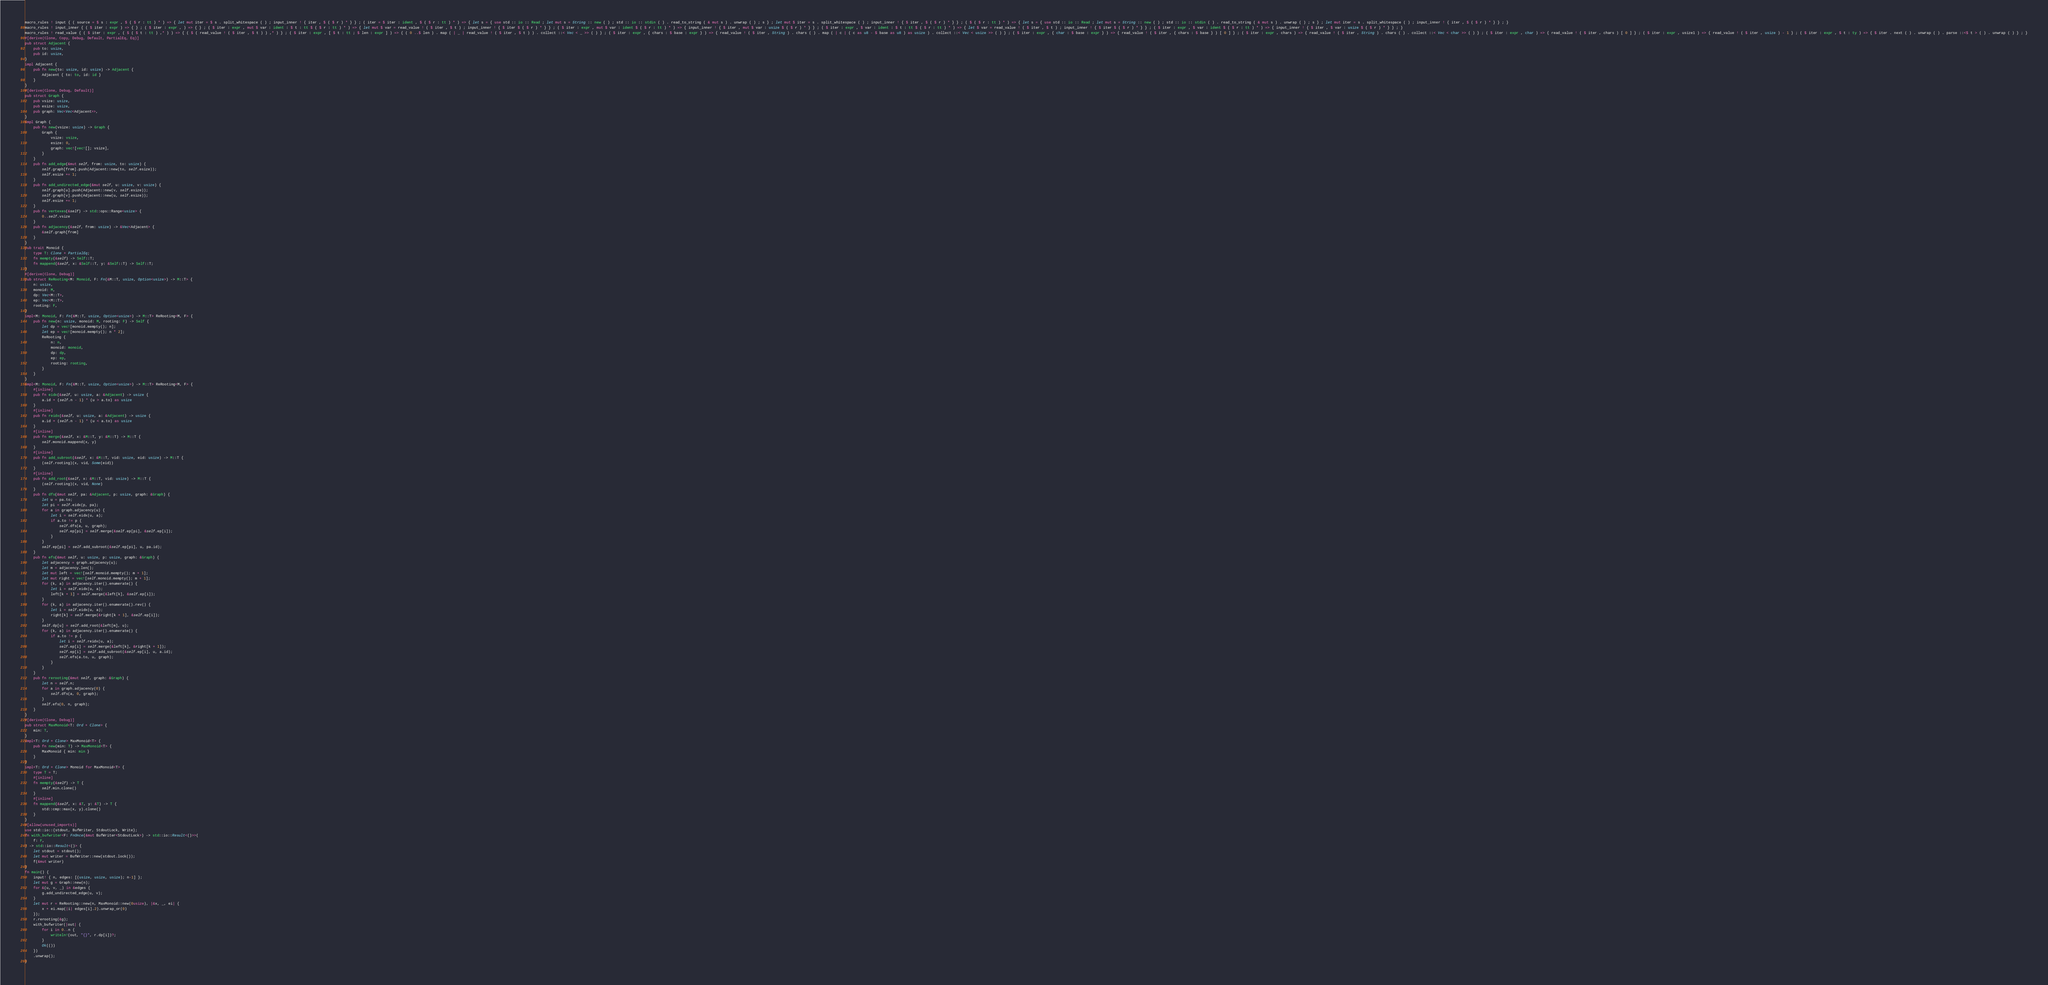Convert code to text. <code><loc_0><loc_0><loc_500><loc_500><_Rust_>macro_rules ! input { ( source = $ s : expr , $ ( $ r : tt ) * ) => { let mut iter = $ s . split_whitespace ( ) ; input_inner ! { iter , $ ( $ r ) * } } ; ( iter = $ iter : ident , $ ( $ r : tt ) * ) => { let s = { use std :: io :: Read ; let mut s = String :: new ( ) ; std :: io :: stdin ( ) . read_to_string ( & mut s ) . unwrap ( ) ; s } ; let mut $ iter = s . split_whitespace ( ) ; input_inner ! { $ iter , $ ( $ r ) * } } ; ( $ ( $ r : tt ) * ) => { let s = { use std :: io :: Read ; let mut s = String :: new ( ) ; std :: io :: stdin ( ) . read_to_string ( & mut s ) . unwrap ( ) ; s } ; let mut iter = s . split_whitespace ( ) ; input_inner ! { iter , $ ( $ r ) * } } ; }
macro_rules ! input_inner { ( $ iter : expr ) => { } ; ( $ iter : expr , ) => { } ; ( $ iter : expr , mut $ var : ident : $ t : tt $ ( $ r : tt ) * ) => { let mut $ var = read_value ! ( $ iter , $ t ) ; input_inner ! { $ iter $ ( $ r ) * } } ; ( $ iter : expr , mut $ var : ident $ ( $ r : tt ) * ) => { input_inner ! { $ iter , mut $ var : usize $ ( $ r ) * } } ; ( $ iter : expr , $ var : ident : $ t : tt $ ( $ r : tt ) * ) => { let $ var = read_value ! ( $ iter , $ t ) ; input_inner ! { $ iter $ ( $ r ) * } } ; ( $ iter : expr , $ var : ident $ ( $ r : tt ) * ) => { input_inner ! { $ iter , $ var : usize $ ( $ r ) * } } ; }
macro_rules ! read_value { ( $ iter : expr , ( $ ( $ t : tt ) ,* ) ) => { ( $ ( read_value ! ( $ iter , $ t ) ) ,* ) } ; ( $ iter : expr , [ $ t : tt ; $ len : expr ] ) => { ( 0 ..$ len ) . map ( | _ | read_value ! ( $ iter , $ t ) ) . collect ::< Vec < _ >> ( ) } ; ( $ iter : expr , { chars : $ base : expr } ) => { read_value ! ( $ iter , String ) . chars ( ) . map ( | c | ( c as u8 - $ base as u8 ) as usize ) . collect ::< Vec < usize >> ( ) } ; ( $ iter : expr , { char : $ base : expr } ) => { read_value ! ( $ iter , { chars : $ base } ) [ 0 ] } ; ( $ iter : expr , chars ) => { read_value ! ( $ iter , String ) . chars ( ) . collect ::< Vec < char >> ( ) } ; ( $ iter : expr , char ) => { read_value ! ( $ iter , chars ) [ 0 ] } ; ( $ iter : expr , usize1 ) => { read_value ! ( $ iter , usize ) - 1 } ; ( $ iter : expr , $ t : ty ) => { $ iter . next ( ) . unwrap ( ) . parse ::<$ t > ( ) . unwrap ( ) } ; }
#[derive(Clone, Copy, Debug, Default, PartialEq, Eq)]
pub struct Adjacent {
    pub to: usize,
    pub id: usize,
}
impl Adjacent {
    pub fn new(to: usize, id: usize) -> Adjacent {
        Adjacent { to: to, id: id }
    }
}
#[derive(Clone, Debug, Default)]
pub struct Graph {
    pub vsize: usize,
    pub esize: usize,
    pub graph: Vec<Vec<Adjacent>>,
}
impl Graph {
    pub fn new(vsize: usize) -> Graph {
        Graph {
            vsize: vsize,
            esize: 0,
            graph: vec![vec![]; vsize],
        }
    }
    pub fn add_edge(&mut self, from: usize, to: usize) {
        self.graph[from].push(Adjacent::new(to, self.esize));
        self.esize += 1;
    }
    pub fn add_undirected_edge(&mut self, u: usize, v: usize) {
        self.graph[u].push(Adjacent::new(v, self.esize));
        self.graph[v].push(Adjacent::new(u, self.esize));
        self.esize += 1;
    }
    pub fn vertexes(&self) -> std::ops::Range<usize> {
        0..self.vsize
    }
    pub fn adjacency(&self, from: usize) -> &Vec<Adjacent> {
        &self.graph[from]
    }
}
pub trait Monoid {
    type T: Clone + PartialEq;
    fn mempty(&self) -> Self::T;
    fn mappend(&self, x: &Self::T, y: &Self::T) -> Self::T;
}
#[derive(Clone, Debug)]
pub struct ReRooting<M: Monoid, F: Fn(&M::T, usize, Option<usize>) -> M::T> {
    n: usize,
    monoid: M,
    dp: Vec<M::T>,
    ep: Vec<M::T>,
    rooting: F,
}
impl<M: Monoid, F: Fn(&M::T, usize, Option<usize>) -> M::T> ReRooting<M, F> {
    pub fn new(n: usize, monoid: M, rooting: F) -> Self {
        let dp = vec![monoid.mempty(); n];
        let ep = vec![monoid.mempty(); n * 2];
        ReRooting {
            n: n,
            monoid: monoid,
            dp: dp,
            ep: ep,
            rooting: rooting,
        }
    }
}
impl<M: Monoid, F: Fn(&M::T, usize, Option<usize>) -> M::T> ReRooting<M, F> {
    #[inline]
    pub fn eidx(&self, u: usize, a: &Adjacent) -> usize {
        a.id + (self.n - 1) * (u > a.to) as usize
    }
    #[inline]
    pub fn reidx(&self, u: usize, a: &Adjacent) -> usize {
        a.id + (self.n - 1) * (u < a.to) as usize
    }
    #[inline]
    pub fn merge(&self, x: &M::T, y: &M::T) -> M::T {
        self.monoid.mappend(x, y)
    }
    #[inline]
    pub fn add_subroot(&self, x: &M::T, vid: usize, eid: usize) -> M::T {
        (self.rooting)(x, vid, Some(eid))
    }
    #[inline]
    pub fn add_root(&self, x: &M::T, vid: usize) -> M::T {
        (self.rooting)(x, vid, None)
    }
    pub fn dfs(&mut self, pa: &Adjacent, p: usize, graph: &Graph) {
        let u = pa.to;
        let pi = self.eidx(p, pa);
        for a in graph.adjacency(u) {
            let i = self.eidx(u, a);
            if a.to != p {
                self.dfs(a, u, graph);
                self.ep[pi] = self.merge(&self.ep[pi], &self.ep[i]);
            }
        }
        self.ep[pi] = self.add_subroot(&self.ep[pi], u, pa.id);
    }
    pub fn efs(&mut self, u: usize, p: usize, graph: &Graph) {
        let adjacency = graph.adjacency(u);
        let m = adjacency.len();
        let mut left = vec![self.monoid.mempty(); m + 1];
        let mut right = vec![self.monoid.mempty(); m + 1];
        for (k, a) in adjacency.iter().enumerate() {
            let i = self.eidx(u, a);
            left[k + 1] = self.merge(&left[k], &self.ep[i]);
        }
        for (k, a) in adjacency.iter().enumerate().rev() {
            let i = self.eidx(u, a);
            right[k] = self.merge(&right[k + 1], &self.ep[i]);
        }
        self.dp[u] = self.add_root(&left[m], u);
        for (k, a) in adjacency.iter().enumerate() {
            if a.to != p {
                let i = self.reidx(u, a);
                self.ep[i] = self.merge(&left[k], &right[k + 1]);
                self.ep[i] = self.add_subroot(&self.ep[i], u, a.id);
                self.efs(a.to, u, graph);
            }
        }
    }
    pub fn rerooting(&mut self, graph: &Graph) {
        let n = self.n;
        for a in graph.adjacency(0) {
            self.dfs(a, 0, graph);
        }
        self.efs(0, n, graph);
    }
}
#[derive(Clone, Debug)]
pub struct MaxMonoid<T: Ord + Clone> {
    min: T,
}
impl<T: Ord + Clone> MaxMonoid<T> {
    pub fn new(min: T) -> MaxMonoid<T> {
        MaxMonoid { min: min }
    }
}
impl<T: Ord + Clone> Monoid for MaxMonoid<T> {
    type T = T;
    #[inline]
    fn mempty(&self) -> T {
        self.min.clone()
    }
    #[inline]
    fn mappend(&self, x: &T, y: &T) -> T {
        std::cmp::max(x, y).clone()
    }
}
#[allow(unused_imports)]
use std::io::{stdout, BufWriter, StdoutLock, Write};
fn with_bufwriter<F: FnOnce(&mut BufWriter<StdoutLock>) -> std::io::Result<()>>(
    f: F,
) -> std::io::Result<()> {
    let stdout = stdout();
    let mut writer = BufWriter::new(stdout.lock());
    f(&mut writer)
}
fn main() {
    input! { n, edges: [(usize, usize, usize); n-1] };
    let mut g = Graph::new(n);
    for &(u, v, _) in &edges {
        g.add_undirected_edge(u, v);
    }
    let mut r = ReRooting::new(n, MaxMonoid::new(0usize), |&x, _, ei| {
        x + ei.map(|i| edges[i].2).unwrap_or(0)
    });
    r.rerooting(&g);
    with_bufwriter(|out| {
        for i in 0..n {
            writeln!(out, "{}", r.dp[i])?;
        }
        Ok(())
    })
    .unwrap();
}

</code> 